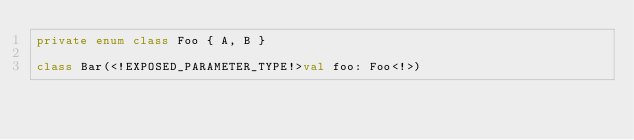<code> <loc_0><loc_0><loc_500><loc_500><_Kotlin_>private enum class Foo { A, B }

class Bar(<!EXPOSED_PARAMETER_TYPE!>val foo: Foo<!>)</code> 